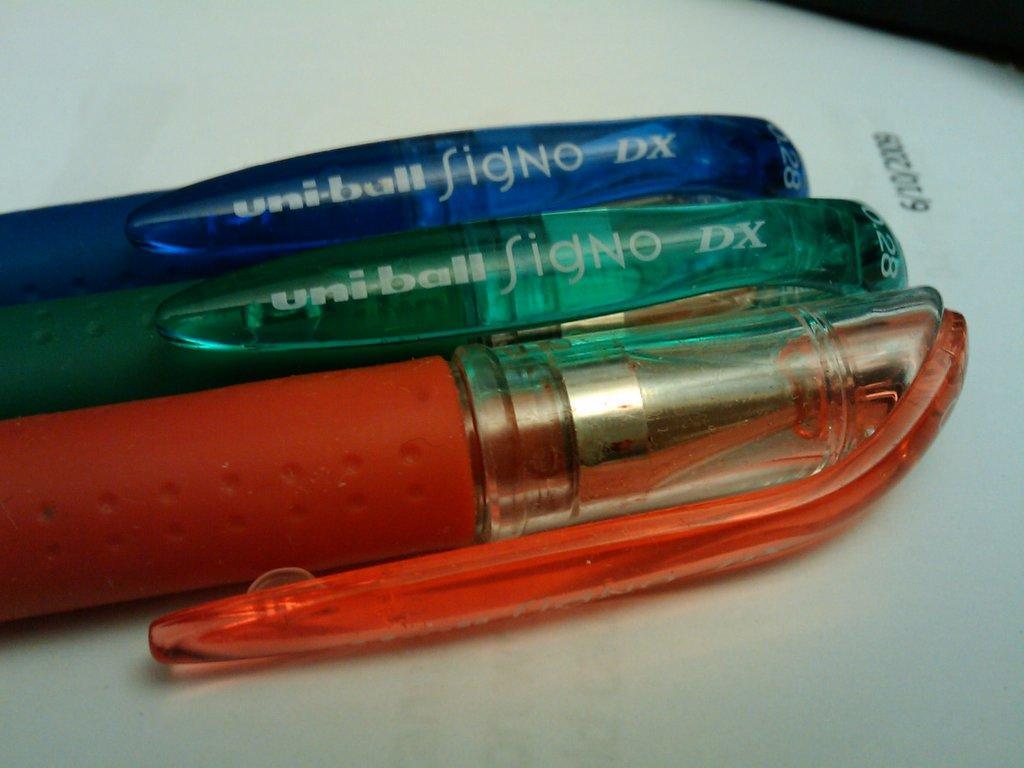Please provide a concise description of this image. In this image, we can see a table, on the table, we can see three pens which are blue, green and red color. In the right corner, we can see an object which is in black color. 